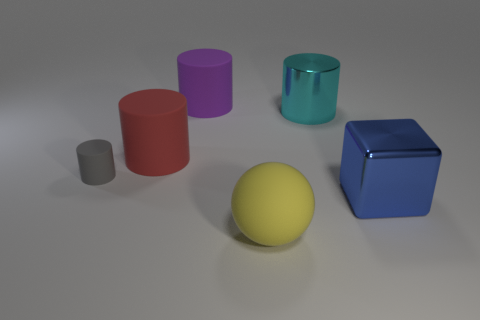Subtract all cyan cubes. Subtract all red balls. How many cubes are left? 1 Add 1 big red matte things. How many objects exist? 7 Subtract all spheres. How many objects are left? 5 Subtract all metal cylinders. Subtract all big purple matte cylinders. How many objects are left? 4 Add 2 big cyan metallic cylinders. How many big cyan metallic cylinders are left? 3 Add 3 big blue blocks. How many big blue blocks exist? 4 Subtract 1 blue blocks. How many objects are left? 5 